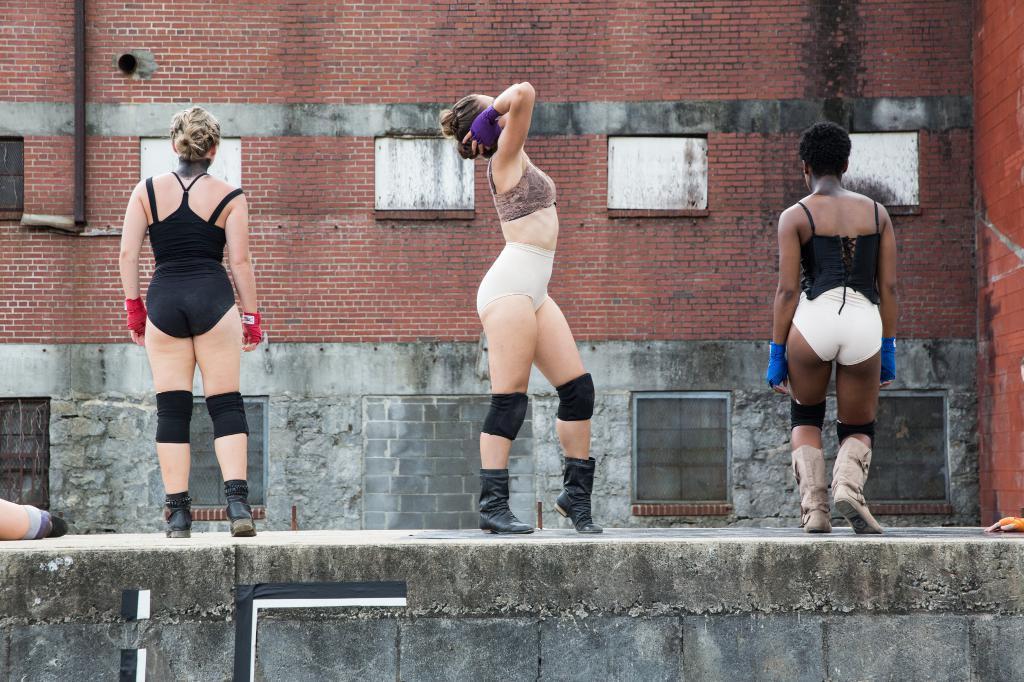Could you give a brief overview of what you see in this image? In this picture I can see few woman standing and looks like a building in the back and I can see a human leg on the left side of the picture and I can see a human hand on the right side of the picture. 